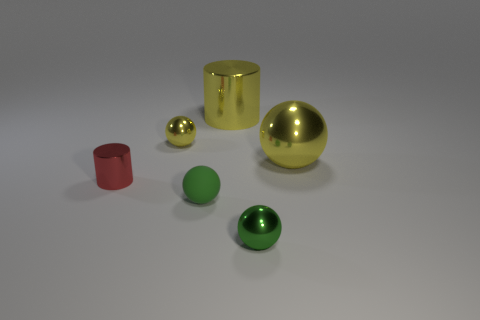Add 1 large green cylinders. How many objects exist? 7 Subtract all small matte balls. How many balls are left? 3 Subtract all yellow cylinders. How many green spheres are left? 2 Subtract all yellow spheres. How many spheres are left? 2 Subtract 1 spheres. How many spheres are left? 3 Subtract all brown cylinders. Subtract all gray cubes. How many cylinders are left? 2 Subtract all big metal cylinders. Subtract all green spheres. How many objects are left? 3 Add 6 tiny balls. How many tiny balls are left? 9 Add 3 small red metallic cylinders. How many small red metallic cylinders exist? 4 Subtract 0 blue blocks. How many objects are left? 6 